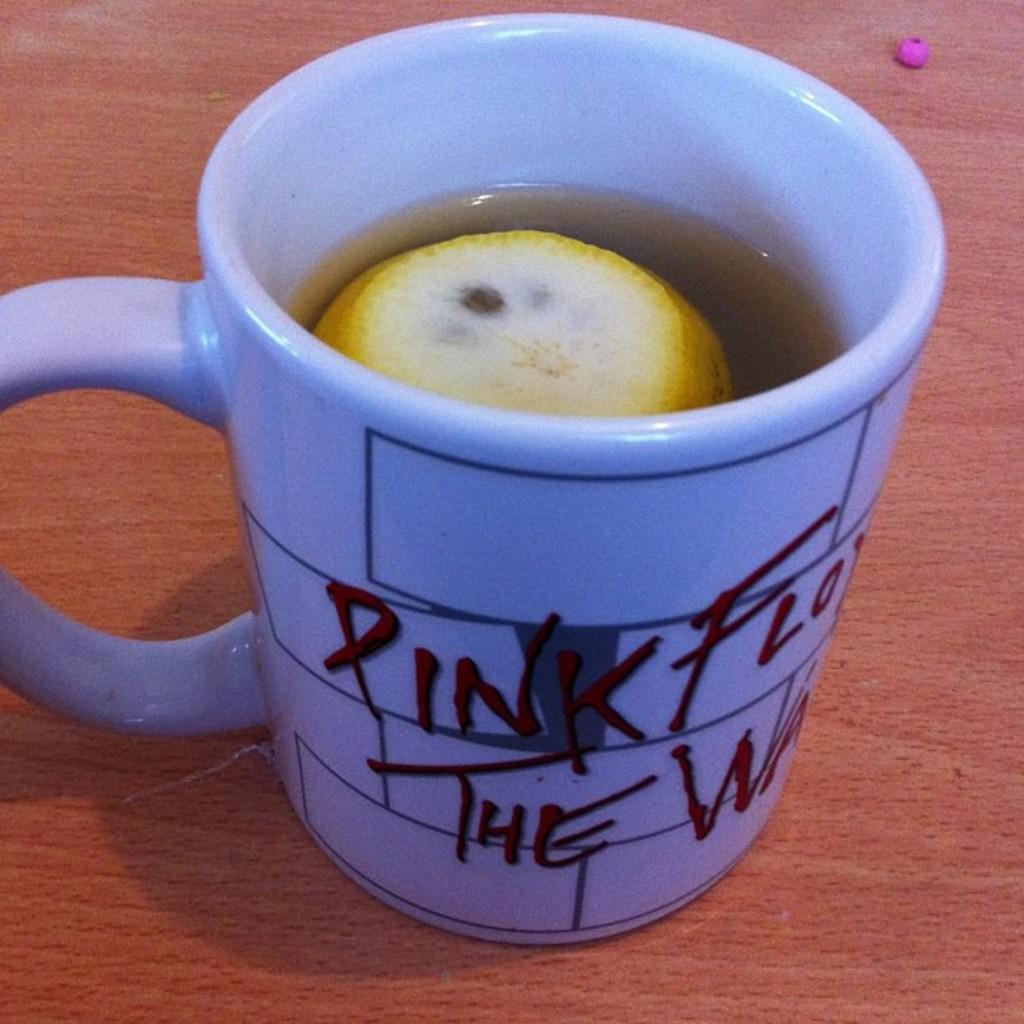Provide a one-sentence caption for the provided image. a coffee mug that says pink flow and lemon in it. 